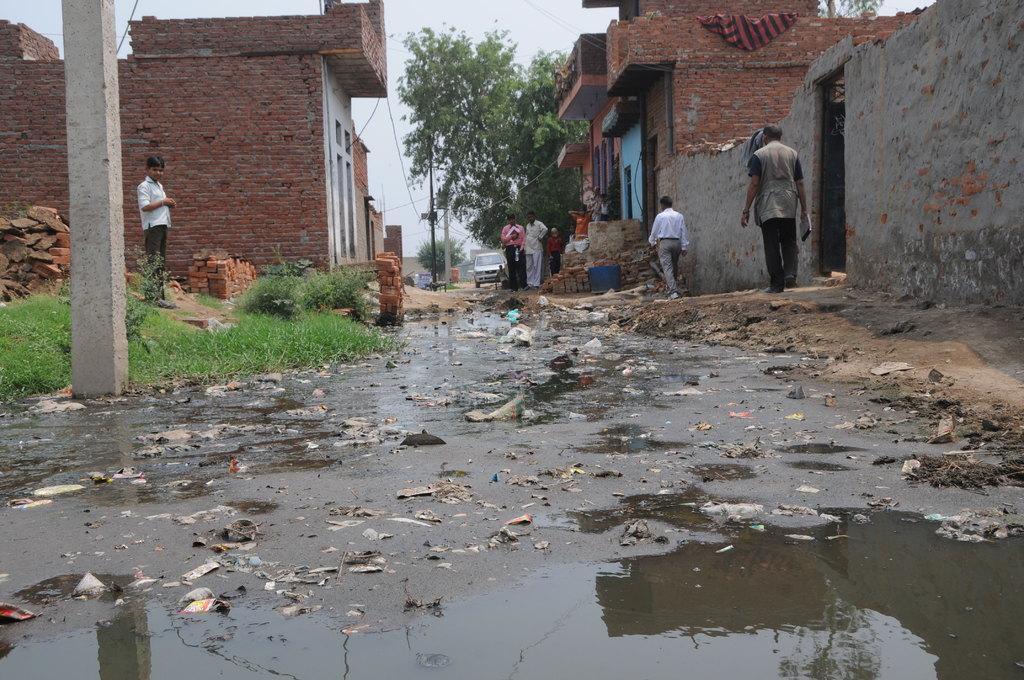In one or two sentences, can you explain what this image depicts? In the center of the image we can see buildings, poles, trees, some persons, bricks, car, container, door. At the top of the image there is a sky. At the bottom of the image we can see drainage water with waste. In the middle of the image grass is there. 